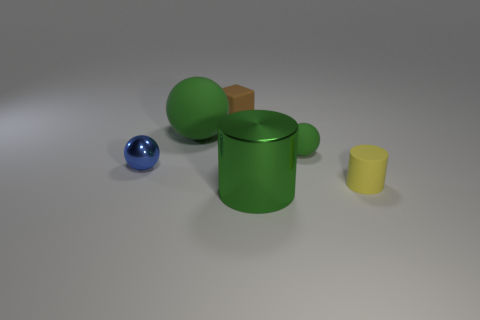What can you infer about the size of the objects relative to each other? The objects in the image vary in size, with the yellow cylinder being the smallest and the green cylindrical object being the largest. The objects are arranged in a manner that gives the viewer a sense of depth and scale, with the differing sizes creating a hierarchy that can be visually interpreted. 